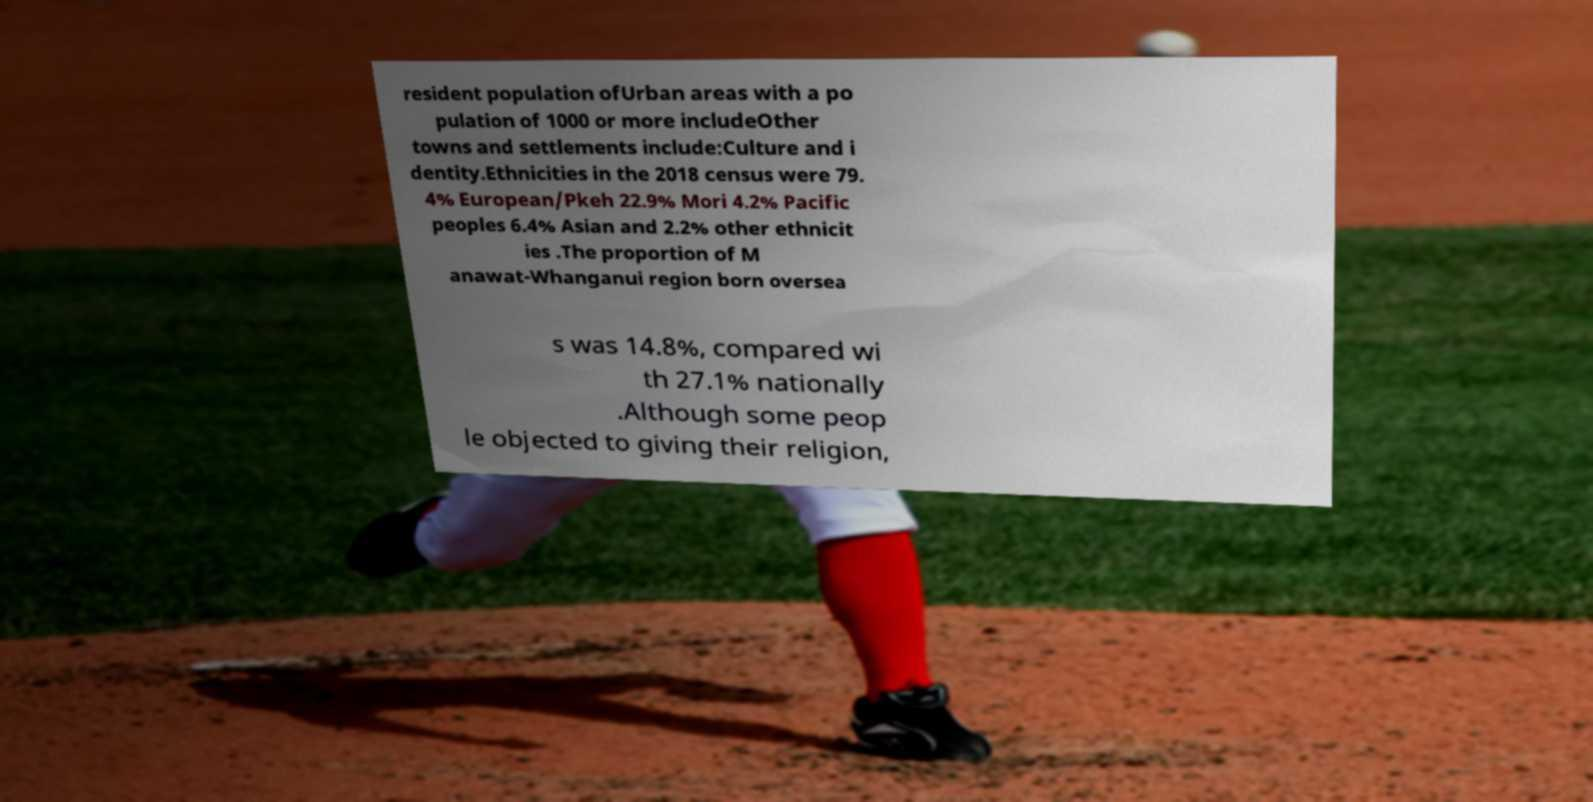I need the written content from this picture converted into text. Can you do that? resident population ofUrban areas with a po pulation of 1000 or more includeOther towns and settlements include:Culture and i dentity.Ethnicities in the 2018 census were 79. 4% European/Pkeh 22.9% Mori 4.2% Pacific peoples 6.4% Asian and 2.2% other ethnicit ies .The proportion of M anawat-Whanganui region born oversea s was 14.8%, compared wi th 27.1% nationally .Although some peop le objected to giving their religion, 